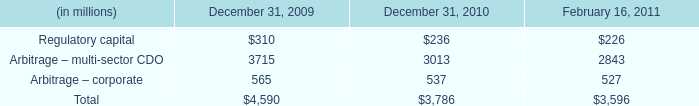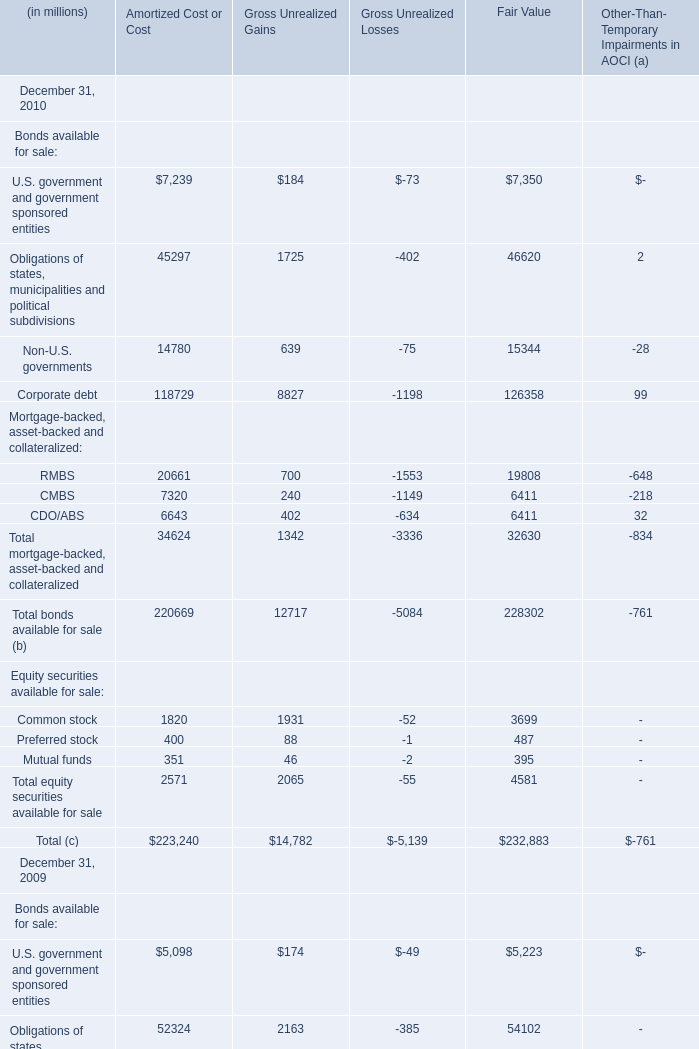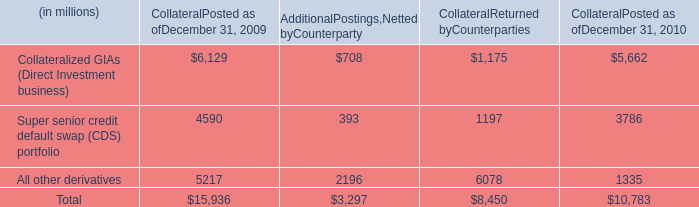What's the growth rate of RMBS of Amortized Cost or Cost in 2010? 
Computations: ((20661 - 32173) / 32173)
Answer: -0.35782. 